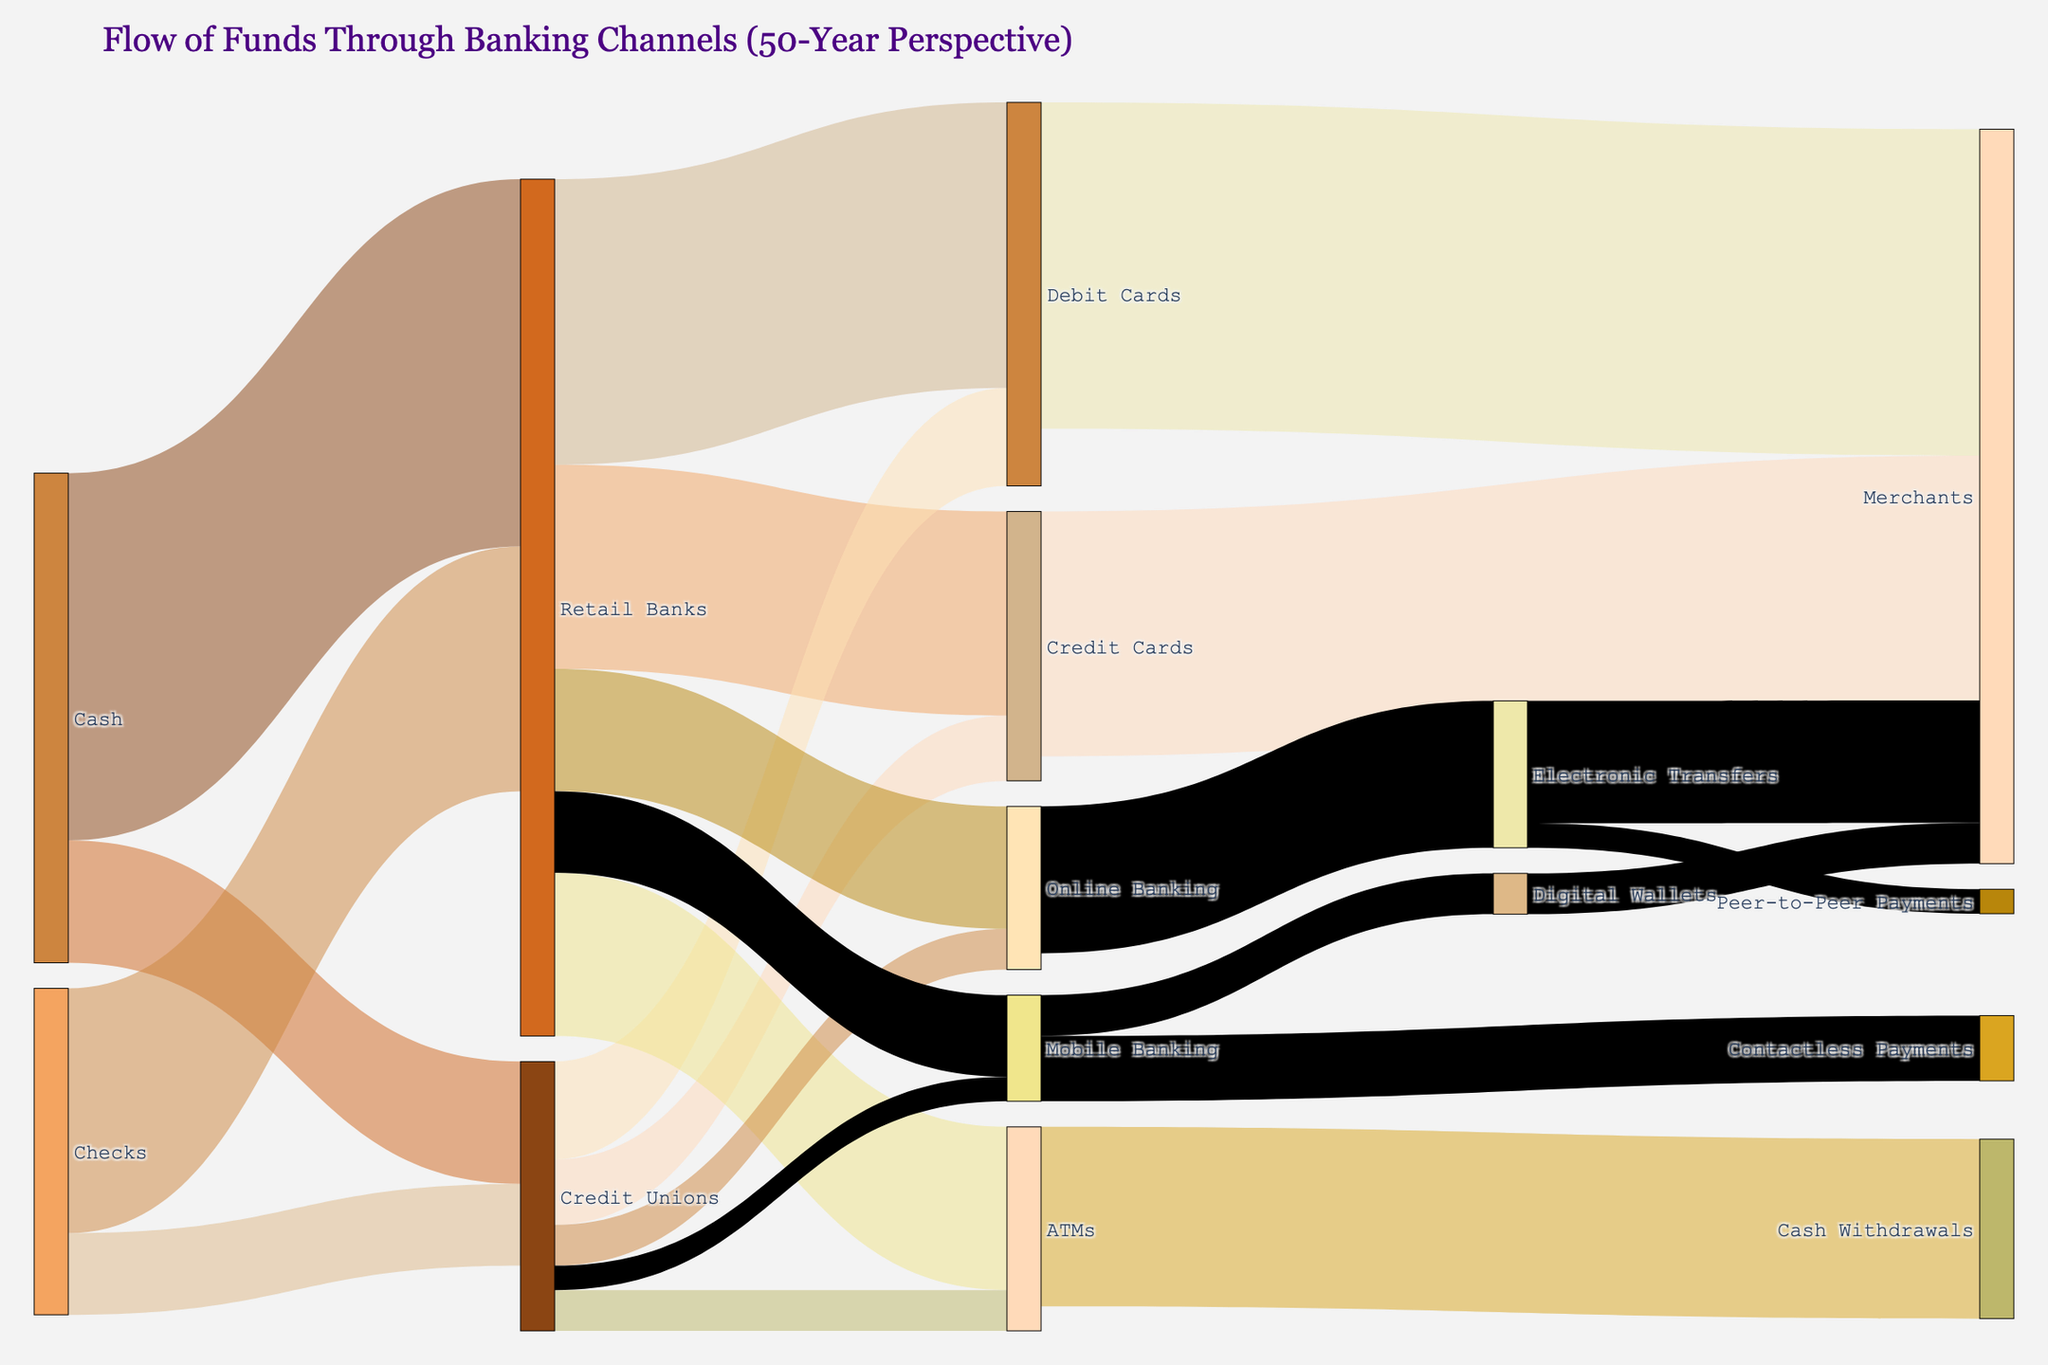what is the total flow to retailers from credit cards? From Credit Cards to Merchants the value is 30.
Answer: 30 Which banking channel received more funds from cash? Compare the funds received by Retail Banks (45) and Credit Unions (15). Retail Banks received more.
Answer: Retail Banks How much total value do retail banks handle from cash and checks combined? Summing the values from Cash (45) and Checks (30) to Retail Banks results in 75.
Answer: 75 How does the flow from Retail Banks to ATMs compare with the flow from Credit Unions to ATMs? Retail Banks to ATMs is 20, while Credit Unions to ATMs is 5. 20 is greater than 5.
Answer: 20 is greater than 5 What is the total flow of funds moving into Debit Cards? Add values from Retail Banks (35) and Credit Unions (12) to Debit Cards, resulting in 47.
Answer: 47 Which payment method has greater funds received by merchants, credit cards or electronic transfers? Compare Credit Cards to Merchants (30) and Electronic Transfers to Merchants (15). 30 is greater than 15.
Answer: Credit Cards What is the total flow moved through mobile banking channels? Sum values: Mobile Banking (10 from Retail Banks + 3 from Credit Unions) = 13, then sum flows from Mobile Banking to Contactless Payments (8) and Digital Wallets (5), resulting in 13.
Answer: 13 How much of the total flow ends up as cash withdrawals from ATMs? The total is directly given by ATMs to Cash Withdrawals (22).
Answer: 22 From which source do digital wallets receive funds? From Mobile Banking to Digital Wallets with a value of 5.
Answer: Mobile Banking 